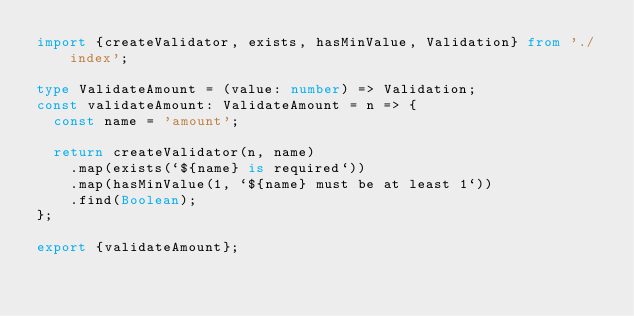<code> <loc_0><loc_0><loc_500><loc_500><_TypeScript_>import {createValidator, exists, hasMinValue, Validation} from './index';

type ValidateAmount = (value: number) => Validation;
const validateAmount: ValidateAmount = n => {
  const name = 'amount';

  return createValidator(n, name)
    .map(exists(`${name} is required`))
    .map(hasMinValue(1, `${name} must be at least 1`))
    .find(Boolean);
};

export {validateAmount};
</code> 